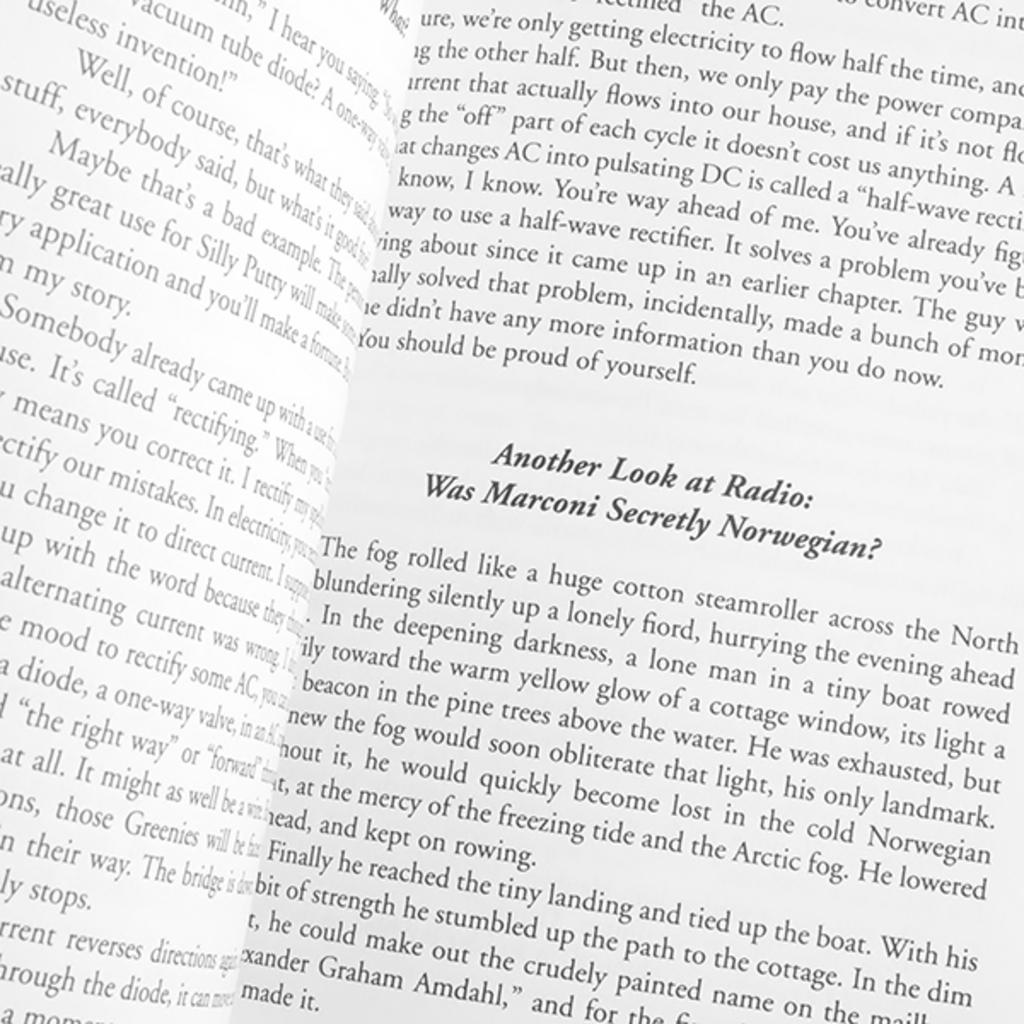<image>
Create a compact narrative representing the image presented. An open book on a page where the paragraph heading is "Another Look at Radio: Was Marconi Secretly Norwegian?" 